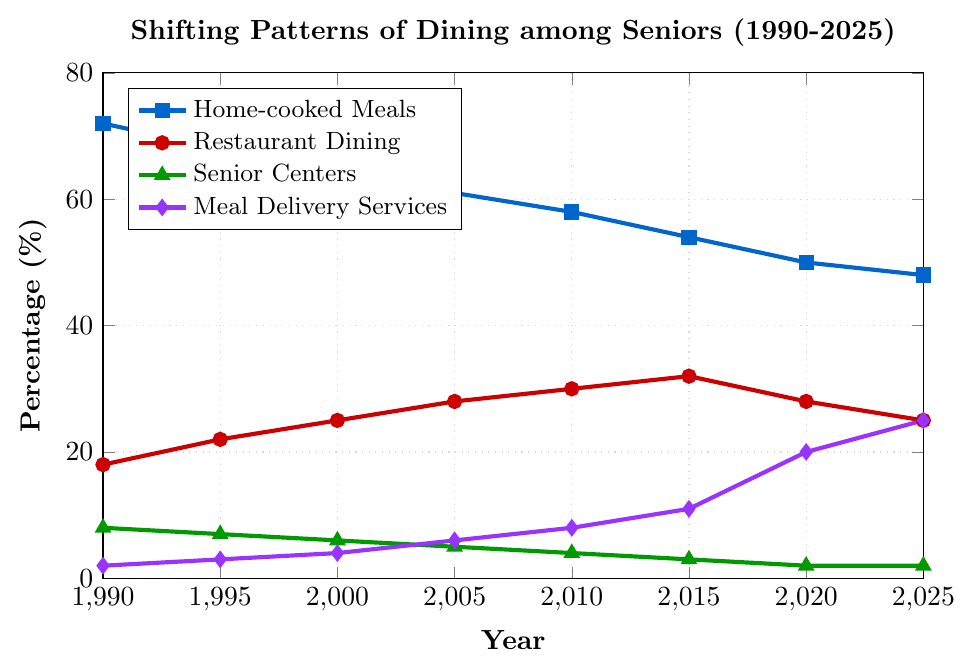Which type of meal option has seen the biggest increase in percentage from 1990 to 2025? First, identify the percentage values for each meal option in both 1990 and 2025. The increase for Home-cooked Meals is (72 - 48) = 24% decrease, for Restaurant Dining, it’s (25 - 18) = 7% increase, for Senior Centers, it’s (2 - 8) = 6% decrease, and for Meal Delivery Services, it’s (25 - 2) = 23% increase. Thus, Meal Delivery Services saw the biggest increase.
Answer: Meal Delivery Services Between which years did Home-cooked Meals see the largest decline in percentage? Calculate the yearly differences. From 1990 to 1995, it’s (72 - 68) = 4%, from 1995 to 2000, it’s (68 - 65) = 3%, from 2000 to 2005, it’s (65 - 61) = 4%, from 2005 to 2010, it’s (61 - 58) = 3%, from 2010 to 2015, it’s (58 - 54) = 4%, and from 2015 to 2020, it’s (54 - 50) = 4%, and from 2020 to 2025, it’s (50 - 48) = 2%. The largest drop is thus 4% occurring between 1990-1995, 2000-2005, 2010-2015.
Answer: 1990-1995, 2000-2005, 2010-2015 In which year did Restaurant Dining reach its peak percentage? Refer to the plot lines; Restaurant Dining starts from 18% in 1990, increases over the next periods, peaking at 32% in 2015 before declining. So the peak year is 2015.
Answer: 2015 By how much did Senior Center meals decrease from 2000 to 2025? Read the Senior Centers' values for both years: 6% in 2000 and 2% in 2025. The decrease is (6 - 2) = 4%.
Answer: 4% Which meal option had the least change in percentage from 1990 to 2025? Calculate the absolute differences for each option over the period: Home-cooked Meals: (72 - 48) = 24%, Restaurant Dining: (25 - 18) = 7%, Senior Centers: (8 - 2) = 6%, Meal Delivery Services: (25 - 2) = 23%. Senior Centers had the least change.
Answer: Senior Centers Compare Restaurant Dining and Meal Delivery Services percentages in 2020. Which one is higher? In 2020, Restaurant Dining (28%) and Meal Delivery Services (20%). So, Restaurant Dining is higher.
Answer: Restaurant Dining What is the sum of the percentages of Home-cooked Meals and Restaurant Dining in 2005? Refer to the percentages in 2005: Home-cooked Meals (61%) and Restaurant Dining (28%). Sum them up: 61% + 28% = 89%.
Answer: 89% What is the average percentage of Meal Delivery Services over the years shown? Sum the Meal Delivery Services percentages from each year: 2, 3, 4, 6, 8, 11, 20, 25. Total is 79. The number of years is 8. Average is 79/8 = 9.875.
Answer: 9.875 